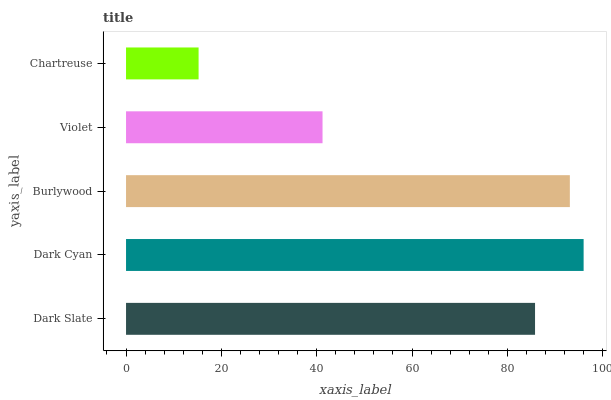Is Chartreuse the minimum?
Answer yes or no. Yes. Is Dark Cyan the maximum?
Answer yes or no. Yes. Is Burlywood the minimum?
Answer yes or no. No. Is Burlywood the maximum?
Answer yes or no. No. Is Dark Cyan greater than Burlywood?
Answer yes or no. Yes. Is Burlywood less than Dark Cyan?
Answer yes or no. Yes. Is Burlywood greater than Dark Cyan?
Answer yes or no. No. Is Dark Cyan less than Burlywood?
Answer yes or no. No. Is Dark Slate the high median?
Answer yes or no. Yes. Is Dark Slate the low median?
Answer yes or no. Yes. Is Burlywood the high median?
Answer yes or no. No. Is Dark Cyan the low median?
Answer yes or no. No. 